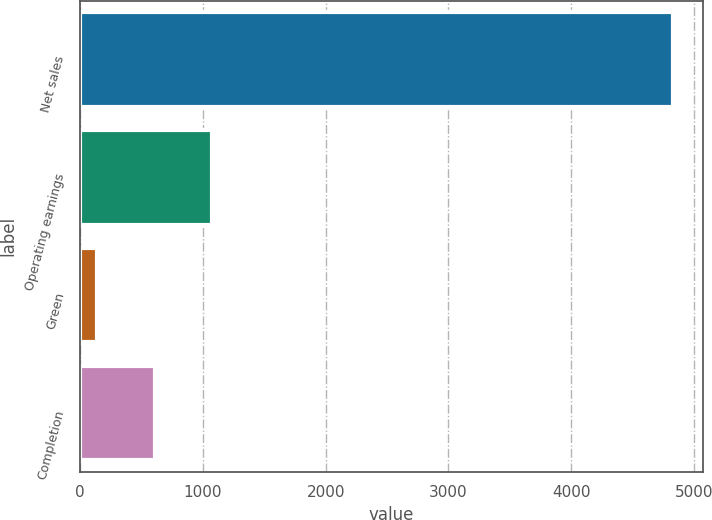Convert chart. <chart><loc_0><loc_0><loc_500><loc_500><bar_chart><fcel>Net sales<fcel>Operating earnings<fcel>Green<fcel>Completion<nl><fcel>4828<fcel>1076<fcel>138<fcel>607<nl></chart> 